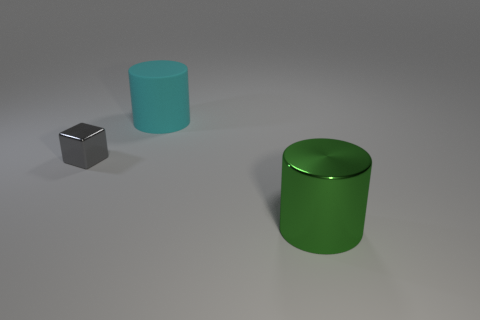What is the color of the large matte thing?
Give a very brief answer. Cyan. What number of big green things are the same material as the green cylinder?
Provide a succinct answer. 0. There is a large object that is behind the small object; how many tiny blocks are left of it?
Provide a short and direct response. 1. How many brown rubber balls are there?
Your answer should be compact. 0. Do the tiny gray block and the big cylinder on the right side of the big cyan matte cylinder have the same material?
Make the answer very short. Yes. Is the color of the large object left of the large shiny cylinder the same as the tiny thing?
Offer a very short reply. No. There is a thing that is both in front of the big cyan thing and right of the gray thing; what material is it?
Give a very brief answer. Metal. What size is the green thing?
Provide a succinct answer. Large. There is a big metal cylinder; is it the same color as the big object behind the big green thing?
Ensure brevity in your answer.  No. How many other objects are there of the same color as the large matte cylinder?
Give a very brief answer. 0. 